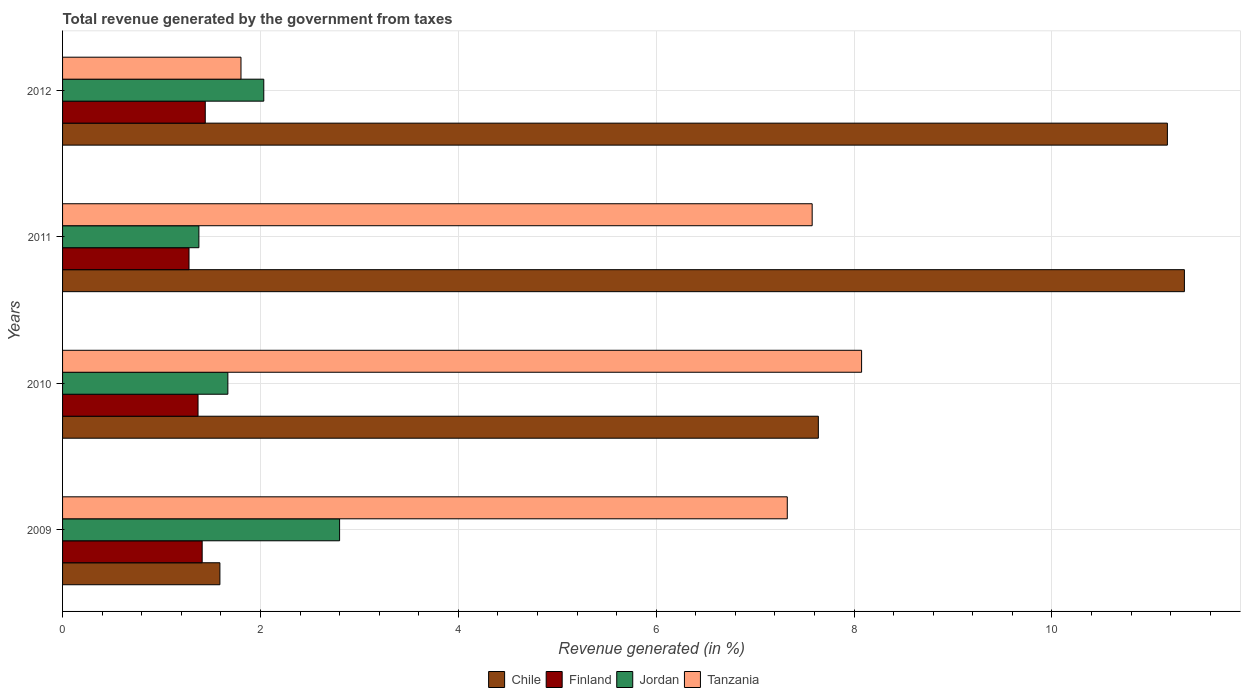How many groups of bars are there?
Provide a short and direct response. 4. How many bars are there on the 4th tick from the bottom?
Offer a very short reply. 4. What is the total revenue generated in Jordan in 2011?
Your answer should be compact. 1.38. Across all years, what is the maximum total revenue generated in Jordan?
Your answer should be compact. 2.8. Across all years, what is the minimum total revenue generated in Finland?
Ensure brevity in your answer.  1.28. What is the total total revenue generated in Tanzania in the graph?
Offer a very short reply. 24.78. What is the difference between the total revenue generated in Jordan in 2010 and that in 2011?
Provide a succinct answer. 0.29. What is the difference between the total revenue generated in Jordan in 2009 and the total revenue generated in Tanzania in 2011?
Offer a very short reply. -4.78. What is the average total revenue generated in Tanzania per year?
Offer a terse response. 6.2. In the year 2011, what is the difference between the total revenue generated in Chile and total revenue generated in Finland?
Your answer should be very brief. 10.06. In how many years, is the total revenue generated in Jordan greater than 10.8 %?
Make the answer very short. 0. What is the ratio of the total revenue generated in Jordan in 2010 to that in 2012?
Keep it short and to the point. 0.82. What is the difference between the highest and the second highest total revenue generated in Chile?
Offer a very short reply. 0.17. What is the difference between the highest and the lowest total revenue generated in Jordan?
Your answer should be very brief. 1.42. What does the 4th bar from the top in 2012 represents?
Provide a short and direct response. Chile. What does the 1st bar from the bottom in 2011 represents?
Your answer should be compact. Chile. Are the values on the major ticks of X-axis written in scientific E-notation?
Keep it short and to the point. No. How many legend labels are there?
Your answer should be compact. 4. What is the title of the graph?
Give a very brief answer. Total revenue generated by the government from taxes. Does "Virgin Islands" appear as one of the legend labels in the graph?
Ensure brevity in your answer.  No. What is the label or title of the X-axis?
Make the answer very short. Revenue generated (in %). What is the Revenue generated (in %) of Chile in 2009?
Offer a very short reply. 1.59. What is the Revenue generated (in %) in Finland in 2009?
Ensure brevity in your answer.  1.41. What is the Revenue generated (in %) in Jordan in 2009?
Your response must be concise. 2.8. What is the Revenue generated (in %) in Tanzania in 2009?
Ensure brevity in your answer.  7.33. What is the Revenue generated (in %) in Chile in 2010?
Your response must be concise. 7.64. What is the Revenue generated (in %) in Finland in 2010?
Provide a succinct answer. 1.37. What is the Revenue generated (in %) in Jordan in 2010?
Keep it short and to the point. 1.67. What is the Revenue generated (in %) of Tanzania in 2010?
Provide a succinct answer. 8.08. What is the Revenue generated (in %) of Chile in 2011?
Provide a short and direct response. 11.34. What is the Revenue generated (in %) of Finland in 2011?
Offer a very short reply. 1.28. What is the Revenue generated (in %) of Jordan in 2011?
Keep it short and to the point. 1.38. What is the Revenue generated (in %) in Tanzania in 2011?
Give a very brief answer. 7.58. What is the Revenue generated (in %) in Chile in 2012?
Your answer should be very brief. 11.17. What is the Revenue generated (in %) of Finland in 2012?
Your response must be concise. 1.44. What is the Revenue generated (in %) in Jordan in 2012?
Make the answer very short. 2.03. What is the Revenue generated (in %) of Tanzania in 2012?
Make the answer very short. 1.8. Across all years, what is the maximum Revenue generated (in %) in Chile?
Your answer should be compact. 11.34. Across all years, what is the maximum Revenue generated (in %) of Finland?
Provide a succinct answer. 1.44. Across all years, what is the maximum Revenue generated (in %) in Jordan?
Give a very brief answer. 2.8. Across all years, what is the maximum Revenue generated (in %) in Tanzania?
Offer a terse response. 8.08. Across all years, what is the minimum Revenue generated (in %) in Chile?
Your answer should be very brief. 1.59. Across all years, what is the minimum Revenue generated (in %) of Finland?
Your response must be concise. 1.28. Across all years, what is the minimum Revenue generated (in %) of Jordan?
Give a very brief answer. 1.38. Across all years, what is the minimum Revenue generated (in %) of Tanzania?
Give a very brief answer. 1.8. What is the total Revenue generated (in %) in Chile in the graph?
Your answer should be compact. 31.74. What is the total Revenue generated (in %) of Finland in the graph?
Ensure brevity in your answer.  5.5. What is the total Revenue generated (in %) in Jordan in the graph?
Your answer should be compact. 7.88. What is the total Revenue generated (in %) in Tanzania in the graph?
Offer a terse response. 24.78. What is the difference between the Revenue generated (in %) in Chile in 2009 and that in 2010?
Offer a terse response. -6.05. What is the difference between the Revenue generated (in %) in Finland in 2009 and that in 2010?
Your answer should be compact. 0.04. What is the difference between the Revenue generated (in %) of Jordan in 2009 and that in 2010?
Your response must be concise. 1.13. What is the difference between the Revenue generated (in %) in Tanzania in 2009 and that in 2010?
Offer a terse response. -0.75. What is the difference between the Revenue generated (in %) of Chile in 2009 and that in 2011?
Your answer should be very brief. -9.75. What is the difference between the Revenue generated (in %) in Finland in 2009 and that in 2011?
Offer a very short reply. 0.13. What is the difference between the Revenue generated (in %) of Jordan in 2009 and that in 2011?
Provide a succinct answer. 1.42. What is the difference between the Revenue generated (in %) in Tanzania in 2009 and that in 2011?
Offer a very short reply. -0.25. What is the difference between the Revenue generated (in %) of Chile in 2009 and that in 2012?
Provide a succinct answer. -9.58. What is the difference between the Revenue generated (in %) of Finland in 2009 and that in 2012?
Provide a succinct answer. -0.03. What is the difference between the Revenue generated (in %) in Jordan in 2009 and that in 2012?
Offer a terse response. 0.77. What is the difference between the Revenue generated (in %) of Tanzania in 2009 and that in 2012?
Provide a succinct answer. 5.52. What is the difference between the Revenue generated (in %) of Chile in 2010 and that in 2011?
Your answer should be compact. -3.7. What is the difference between the Revenue generated (in %) of Finland in 2010 and that in 2011?
Provide a succinct answer. 0.09. What is the difference between the Revenue generated (in %) of Jordan in 2010 and that in 2011?
Provide a succinct answer. 0.29. What is the difference between the Revenue generated (in %) of Tanzania in 2010 and that in 2011?
Your answer should be very brief. 0.5. What is the difference between the Revenue generated (in %) of Chile in 2010 and that in 2012?
Give a very brief answer. -3.53. What is the difference between the Revenue generated (in %) of Finland in 2010 and that in 2012?
Keep it short and to the point. -0.07. What is the difference between the Revenue generated (in %) in Jordan in 2010 and that in 2012?
Offer a terse response. -0.36. What is the difference between the Revenue generated (in %) in Tanzania in 2010 and that in 2012?
Your answer should be very brief. 6.27. What is the difference between the Revenue generated (in %) in Chile in 2011 and that in 2012?
Give a very brief answer. 0.17. What is the difference between the Revenue generated (in %) of Finland in 2011 and that in 2012?
Make the answer very short. -0.16. What is the difference between the Revenue generated (in %) in Jordan in 2011 and that in 2012?
Your response must be concise. -0.66. What is the difference between the Revenue generated (in %) in Tanzania in 2011 and that in 2012?
Provide a succinct answer. 5.77. What is the difference between the Revenue generated (in %) of Chile in 2009 and the Revenue generated (in %) of Finland in 2010?
Provide a succinct answer. 0.22. What is the difference between the Revenue generated (in %) in Chile in 2009 and the Revenue generated (in %) in Jordan in 2010?
Your response must be concise. -0.08. What is the difference between the Revenue generated (in %) of Chile in 2009 and the Revenue generated (in %) of Tanzania in 2010?
Your response must be concise. -6.49. What is the difference between the Revenue generated (in %) of Finland in 2009 and the Revenue generated (in %) of Jordan in 2010?
Offer a terse response. -0.26. What is the difference between the Revenue generated (in %) in Finland in 2009 and the Revenue generated (in %) in Tanzania in 2010?
Ensure brevity in your answer.  -6.67. What is the difference between the Revenue generated (in %) in Jordan in 2009 and the Revenue generated (in %) in Tanzania in 2010?
Give a very brief answer. -5.28. What is the difference between the Revenue generated (in %) of Chile in 2009 and the Revenue generated (in %) of Finland in 2011?
Give a very brief answer. 0.31. What is the difference between the Revenue generated (in %) in Chile in 2009 and the Revenue generated (in %) in Jordan in 2011?
Your response must be concise. 0.21. What is the difference between the Revenue generated (in %) of Chile in 2009 and the Revenue generated (in %) of Tanzania in 2011?
Ensure brevity in your answer.  -5.99. What is the difference between the Revenue generated (in %) in Finland in 2009 and the Revenue generated (in %) in Jordan in 2011?
Make the answer very short. 0.03. What is the difference between the Revenue generated (in %) in Finland in 2009 and the Revenue generated (in %) in Tanzania in 2011?
Provide a short and direct response. -6.17. What is the difference between the Revenue generated (in %) of Jordan in 2009 and the Revenue generated (in %) of Tanzania in 2011?
Ensure brevity in your answer.  -4.78. What is the difference between the Revenue generated (in %) in Chile in 2009 and the Revenue generated (in %) in Finland in 2012?
Offer a terse response. 0.15. What is the difference between the Revenue generated (in %) in Chile in 2009 and the Revenue generated (in %) in Jordan in 2012?
Ensure brevity in your answer.  -0.44. What is the difference between the Revenue generated (in %) of Chile in 2009 and the Revenue generated (in %) of Tanzania in 2012?
Provide a short and direct response. -0.21. What is the difference between the Revenue generated (in %) in Finland in 2009 and the Revenue generated (in %) in Jordan in 2012?
Provide a short and direct response. -0.62. What is the difference between the Revenue generated (in %) of Finland in 2009 and the Revenue generated (in %) of Tanzania in 2012?
Provide a short and direct response. -0.39. What is the difference between the Revenue generated (in %) in Jordan in 2009 and the Revenue generated (in %) in Tanzania in 2012?
Offer a very short reply. 1. What is the difference between the Revenue generated (in %) in Chile in 2010 and the Revenue generated (in %) in Finland in 2011?
Your response must be concise. 6.36. What is the difference between the Revenue generated (in %) of Chile in 2010 and the Revenue generated (in %) of Jordan in 2011?
Your answer should be very brief. 6.26. What is the difference between the Revenue generated (in %) in Chile in 2010 and the Revenue generated (in %) in Tanzania in 2011?
Keep it short and to the point. 0.06. What is the difference between the Revenue generated (in %) in Finland in 2010 and the Revenue generated (in %) in Jordan in 2011?
Keep it short and to the point. -0.01. What is the difference between the Revenue generated (in %) in Finland in 2010 and the Revenue generated (in %) in Tanzania in 2011?
Offer a terse response. -6.21. What is the difference between the Revenue generated (in %) of Jordan in 2010 and the Revenue generated (in %) of Tanzania in 2011?
Make the answer very short. -5.91. What is the difference between the Revenue generated (in %) of Chile in 2010 and the Revenue generated (in %) of Finland in 2012?
Make the answer very short. 6.2. What is the difference between the Revenue generated (in %) of Chile in 2010 and the Revenue generated (in %) of Jordan in 2012?
Your answer should be compact. 5.61. What is the difference between the Revenue generated (in %) of Chile in 2010 and the Revenue generated (in %) of Tanzania in 2012?
Your answer should be very brief. 5.84. What is the difference between the Revenue generated (in %) of Finland in 2010 and the Revenue generated (in %) of Jordan in 2012?
Your answer should be very brief. -0.66. What is the difference between the Revenue generated (in %) of Finland in 2010 and the Revenue generated (in %) of Tanzania in 2012?
Offer a terse response. -0.43. What is the difference between the Revenue generated (in %) of Jordan in 2010 and the Revenue generated (in %) of Tanzania in 2012?
Ensure brevity in your answer.  -0.13. What is the difference between the Revenue generated (in %) of Chile in 2011 and the Revenue generated (in %) of Finland in 2012?
Your answer should be very brief. 9.9. What is the difference between the Revenue generated (in %) in Chile in 2011 and the Revenue generated (in %) in Jordan in 2012?
Keep it short and to the point. 9.31. What is the difference between the Revenue generated (in %) in Chile in 2011 and the Revenue generated (in %) in Tanzania in 2012?
Offer a terse response. 9.54. What is the difference between the Revenue generated (in %) in Finland in 2011 and the Revenue generated (in %) in Jordan in 2012?
Provide a short and direct response. -0.76. What is the difference between the Revenue generated (in %) of Finland in 2011 and the Revenue generated (in %) of Tanzania in 2012?
Offer a very short reply. -0.53. What is the difference between the Revenue generated (in %) of Jordan in 2011 and the Revenue generated (in %) of Tanzania in 2012?
Ensure brevity in your answer.  -0.43. What is the average Revenue generated (in %) in Chile per year?
Your answer should be very brief. 7.93. What is the average Revenue generated (in %) in Finland per year?
Make the answer very short. 1.38. What is the average Revenue generated (in %) of Jordan per year?
Offer a terse response. 1.97. What is the average Revenue generated (in %) of Tanzania per year?
Offer a very short reply. 6.2. In the year 2009, what is the difference between the Revenue generated (in %) in Chile and Revenue generated (in %) in Finland?
Ensure brevity in your answer.  0.18. In the year 2009, what is the difference between the Revenue generated (in %) in Chile and Revenue generated (in %) in Jordan?
Make the answer very short. -1.21. In the year 2009, what is the difference between the Revenue generated (in %) in Chile and Revenue generated (in %) in Tanzania?
Make the answer very short. -5.74. In the year 2009, what is the difference between the Revenue generated (in %) in Finland and Revenue generated (in %) in Jordan?
Offer a very short reply. -1.39. In the year 2009, what is the difference between the Revenue generated (in %) in Finland and Revenue generated (in %) in Tanzania?
Provide a succinct answer. -5.91. In the year 2009, what is the difference between the Revenue generated (in %) of Jordan and Revenue generated (in %) of Tanzania?
Provide a short and direct response. -4.53. In the year 2010, what is the difference between the Revenue generated (in %) of Chile and Revenue generated (in %) of Finland?
Provide a succinct answer. 6.27. In the year 2010, what is the difference between the Revenue generated (in %) of Chile and Revenue generated (in %) of Jordan?
Provide a succinct answer. 5.97. In the year 2010, what is the difference between the Revenue generated (in %) of Chile and Revenue generated (in %) of Tanzania?
Keep it short and to the point. -0.44. In the year 2010, what is the difference between the Revenue generated (in %) of Finland and Revenue generated (in %) of Jordan?
Make the answer very short. -0.3. In the year 2010, what is the difference between the Revenue generated (in %) in Finland and Revenue generated (in %) in Tanzania?
Provide a succinct answer. -6.71. In the year 2010, what is the difference between the Revenue generated (in %) of Jordan and Revenue generated (in %) of Tanzania?
Give a very brief answer. -6.41. In the year 2011, what is the difference between the Revenue generated (in %) of Chile and Revenue generated (in %) of Finland?
Your answer should be compact. 10.06. In the year 2011, what is the difference between the Revenue generated (in %) in Chile and Revenue generated (in %) in Jordan?
Your answer should be compact. 9.96. In the year 2011, what is the difference between the Revenue generated (in %) of Chile and Revenue generated (in %) of Tanzania?
Make the answer very short. 3.76. In the year 2011, what is the difference between the Revenue generated (in %) of Finland and Revenue generated (in %) of Jordan?
Ensure brevity in your answer.  -0.1. In the year 2011, what is the difference between the Revenue generated (in %) of Finland and Revenue generated (in %) of Tanzania?
Ensure brevity in your answer.  -6.3. In the year 2011, what is the difference between the Revenue generated (in %) of Jordan and Revenue generated (in %) of Tanzania?
Ensure brevity in your answer.  -6.2. In the year 2012, what is the difference between the Revenue generated (in %) in Chile and Revenue generated (in %) in Finland?
Your answer should be very brief. 9.72. In the year 2012, what is the difference between the Revenue generated (in %) in Chile and Revenue generated (in %) in Jordan?
Give a very brief answer. 9.13. In the year 2012, what is the difference between the Revenue generated (in %) in Chile and Revenue generated (in %) in Tanzania?
Your answer should be compact. 9.36. In the year 2012, what is the difference between the Revenue generated (in %) of Finland and Revenue generated (in %) of Jordan?
Your answer should be very brief. -0.59. In the year 2012, what is the difference between the Revenue generated (in %) of Finland and Revenue generated (in %) of Tanzania?
Ensure brevity in your answer.  -0.36. In the year 2012, what is the difference between the Revenue generated (in %) in Jordan and Revenue generated (in %) in Tanzania?
Give a very brief answer. 0.23. What is the ratio of the Revenue generated (in %) in Chile in 2009 to that in 2010?
Offer a terse response. 0.21. What is the ratio of the Revenue generated (in %) of Finland in 2009 to that in 2010?
Offer a terse response. 1.03. What is the ratio of the Revenue generated (in %) in Jordan in 2009 to that in 2010?
Ensure brevity in your answer.  1.68. What is the ratio of the Revenue generated (in %) of Tanzania in 2009 to that in 2010?
Provide a succinct answer. 0.91. What is the ratio of the Revenue generated (in %) of Chile in 2009 to that in 2011?
Ensure brevity in your answer.  0.14. What is the ratio of the Revenue generated (in %) in Finland in 2009 to that in 2011?
Keep it short and to the point. 1.1. What is the ratio of the Revenue generated (in %) of Jordan in 2009 to that in 2011?
Offer a terse response. 2.03. What is the ratio of the Revenue generated (in %) of Tanzania in 2009 to that in 2011?
Keep it short and to the point. 0.97. What is the ratio of the Revenue generated (in %) of Chile in 2009 to that in 2012?
Offer a terse response. 0.14. What is the ratio of the Revenue generated (in %) of Finland in 2009 to that in 2012?
Offer a very short reply. 0.98. What is the ratio of the Revenue generated (in %) of Jordan in 2009 to that in 2012?
Ensure brevity in your answer.  1.38. What is the ratio of the Revenue generated (in %) in Tanzania in 2009 to that in 2012?
Provide a succinct answer. 4.06. What is the ratio of the Revenue generated (in %) in Chile in 2010 to that in 2011?
Give a very brief answer. 0.67. What is the ratio of the Revenue generated (in %) in Finland in 2010 to that in 2011?
Make the answer very short. 1.07. What is the ratio of the Revenue generated (in %) of Jordan in 2010 to that in 2011?
Give a very brief answer. 1.21. What is the ratio of the Revenue generated (in %) in Tanzania in 2010 to that in 2011?
Your answer should be very brief. 1.07. What is the ratio of the Revenue generated (in %) in Chile in 2010 to that in 2012?
Ensure brevity in your answer.  0.68. What is the ratio of the Revenue generated (in %) of Finland in 2010 to that in 2012?
Give a very brief answer. 0.95. What is the ratio of the Revenue generated (in %) in Jordan in 2010 to that in 2012?
Give a very brief answer. 0.82. What is the ratio of the Revenue generated (in %) in Tanzania in 2010 to that in 2012?
Give a very brief answer. 4.48. What is the ratio of the Revenue generated (in %) in Chile in 2011 to that in 2012?
Provide a succinct answer. 1.02. What is the ratio of the Revenue generated (in %) in Finland in 2011 to that in 2012?
Give a very brief answer. 0.89. What is the ratio of the Revenue generated (in %) in Jordan in 2011 to that in 2012?
Give a very brief answer. 0.68. What is the ratio of the Revenue generated (in %) of Tanzania in 2011 to that in 2012?
Provide a short and direct response. 4.2. What is the difference between the highest and the second highest Revenue generated (in %) in Chile?
Provide a succinct answer. 0.17. What is the difference between the highest and the second highest Revenue generated (in %) in Finland?
Your answer should be compact. 0.03. What is the difference between the highest and the second highest Revenue generated (in %) in Jordan?
Your answer should be very brief. 0.77. What is the difference between the highest and the second highest Revenue generated (in %) in Tanzania?
Give a very brief answer. 0.5. What is the difference between the highest and the lowest Revenue generated (in %) in Chile?
Keep it short and to the point. 9.75. What is the difference between the highest and the lowest Revenue generated (in %) in Finland?
Offer a very short reply. 0.16. What is the difference between the highest and the lowest Revenue generated (in %) of Jordan?
Offer a terse response. 1.42. What is the difference between the highest and the lowest Revenue generated (in %) of Tanzania?
Offer a terse response. 6.27. 